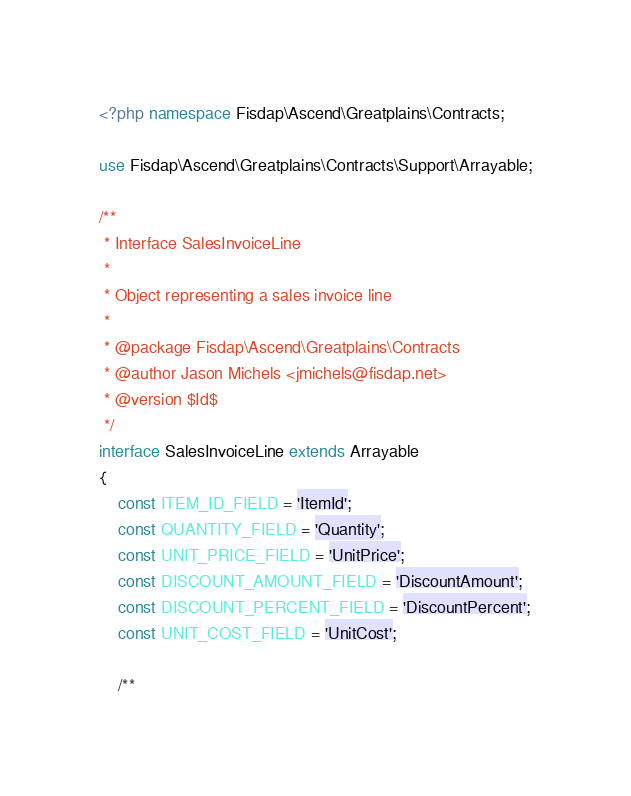<code> <loc_0><loc_0><loc_500><loc_500><_PHP_><?php namespace Fisdap\Ascend\Greatplains\Contracts;

use Fisdap\Ascend\Greatplains\Contracts\Support\Arrayable;

/**
 * Interface SalesInvoiceLine
 *
 * Object representing a sales invoice line
 *
 * @package Fisdap\Ascend\Greatplains\Contracts
 * @author Jason Michels <jmichels@fisdap.net>
 * @version $Id$
 */
interface SalesInvoiceLine extends Arrayable
{
    const ITEM_ID_FIELD = 'ItemId';
    const QUANTITY_FIELD = 'Quantity';
    const UNIT_PRICE_FIELD = 'UnitPrice';
    const DISCOUNT_AMOUNT_FIELD = 'DiscountAmount';
    const DISCOUNT_PERCENT_FIELD = 'DiscountPercent';
    const UNIT_COST_FIELD = 'UnitCost';

    /**</code> 